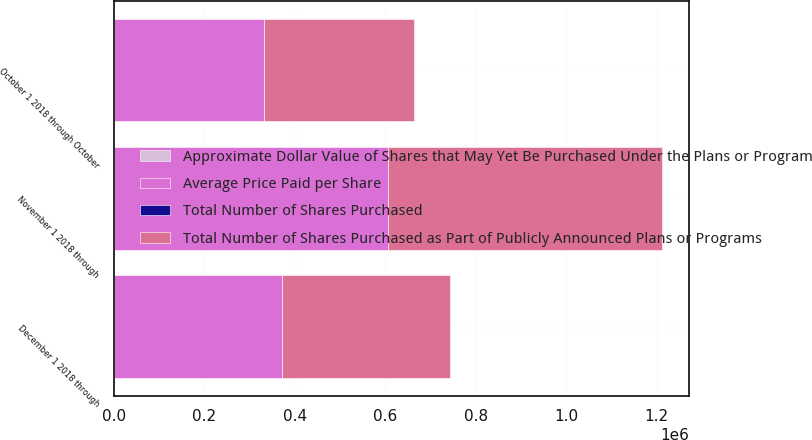<chart> <loc_0><loc_0><loc_500><loc_500><stacked_bar_chart><ecel><fcel>October 1 2018 through October<fcel>November 1 2018 through<fcel>December 1 2018 through<nl><fcel>Average Price Paid per Share<fcel>331812<fcel>605500<fcel>371032<nl><fcel>Approximate Dollar Value of Shares that May Yet Be Purchased Under the Plans or Programs in millions<fcel>120.55<fcel>121.93<fcel>114.76<nl><fcel>Total Number of Shares Purchased as Part of Publicly Announced Plans or Programs<fcel>331812<fcel>605500<fcel>371032<nl><fcel>Total Number of Shares Purchased<fcel>544<fcel>470.2<fcel>427.6<nl></chart> 